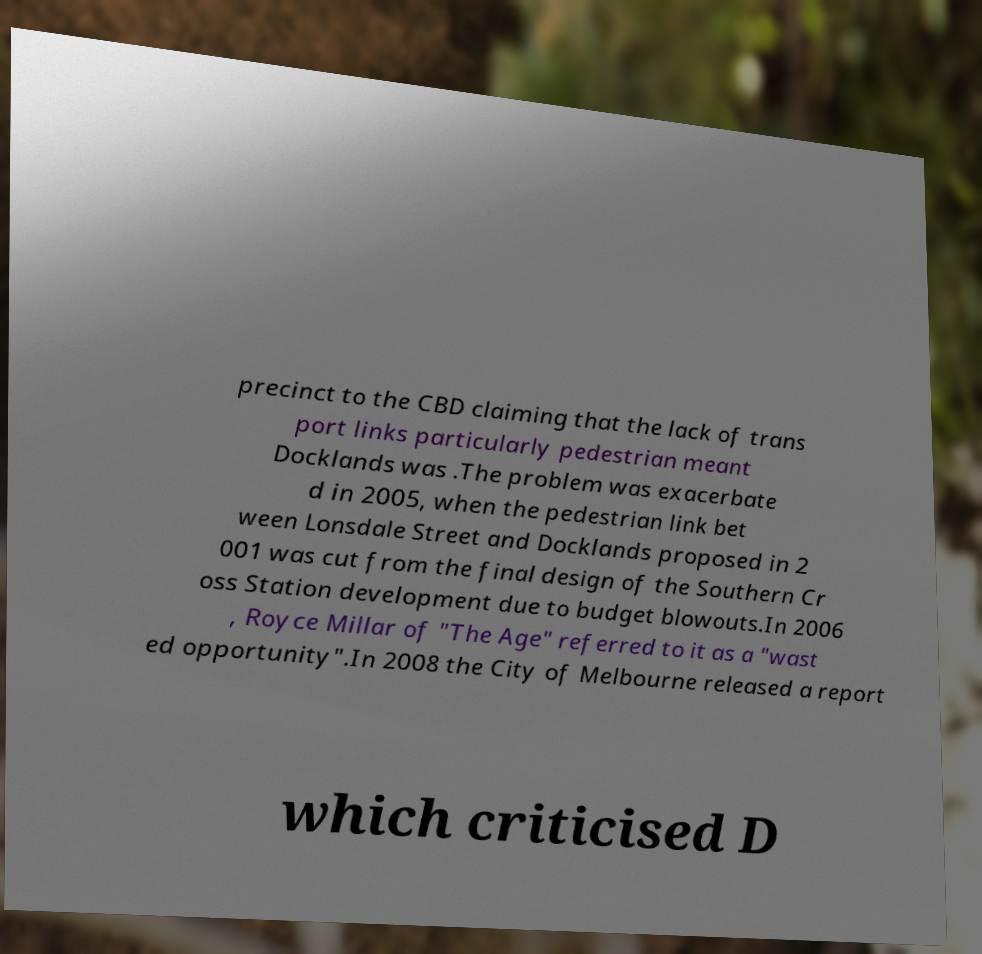There's text embedded in this image that I need extracted. Can you transcribe it verbatim? precinct to the CBD claiming that the lack of trans port links particularly pedestrian meant Docklands was .The problem was exacerbate d in 2005, when the pedestrian link bet ween Lonsdale Street and Docklands proposed in 2 001 was cut from the final design of the Southern Cr oss Station development due to budget blowouts.In 2006 , Royce Millar of "The Age" referred to it as a "wast ed opportunity".In 2008 the City of Melbourne released a report which criticised D 